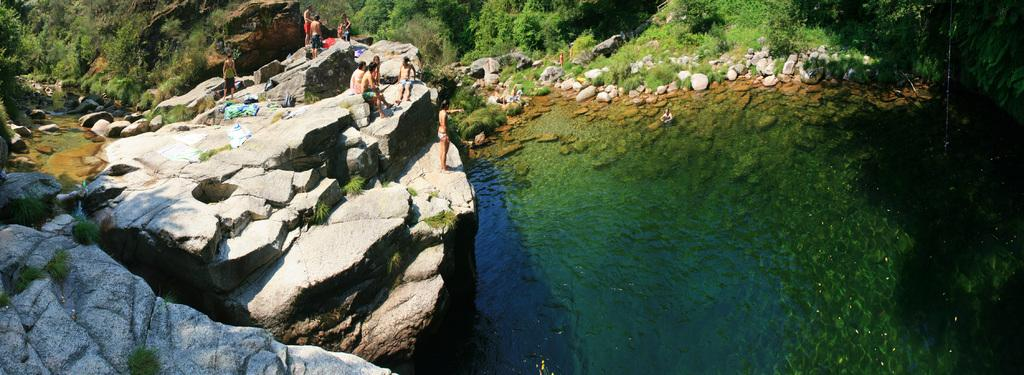What are the people in the image standing on? The people in the image are standing on rocks. What is visible in the background of the image? There is water visible in the image, as well as trees and plants. What type of terrain is depicted in the image? The image features rocks, water, trees, and plants, suggesting a natural, outdoor setting. What type of pie can be smelled in the image? There is no pie present in the image, and therefore no scent can be associated with it. 